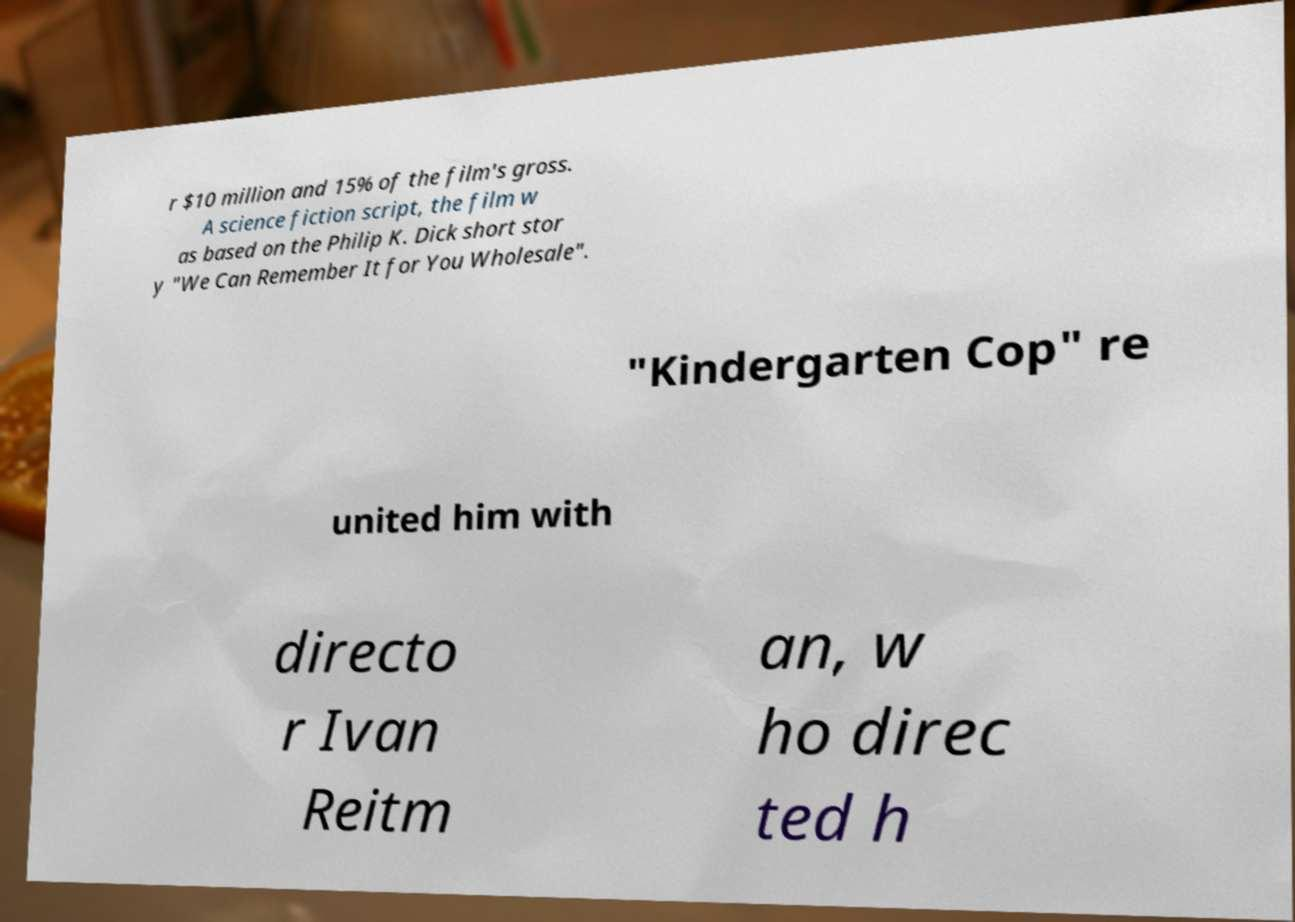What messages or text are displayed in this image? I need them in a readable, typed format. r $10 million and 15% of the film's gross. A science fiction script, the film w as based on the Philip K. Dick short stor y "We Can Remember It for You Wholesale". "Kindergarten Cop" re united him with directo r Ivan Reitm an, w ho direc ted h 